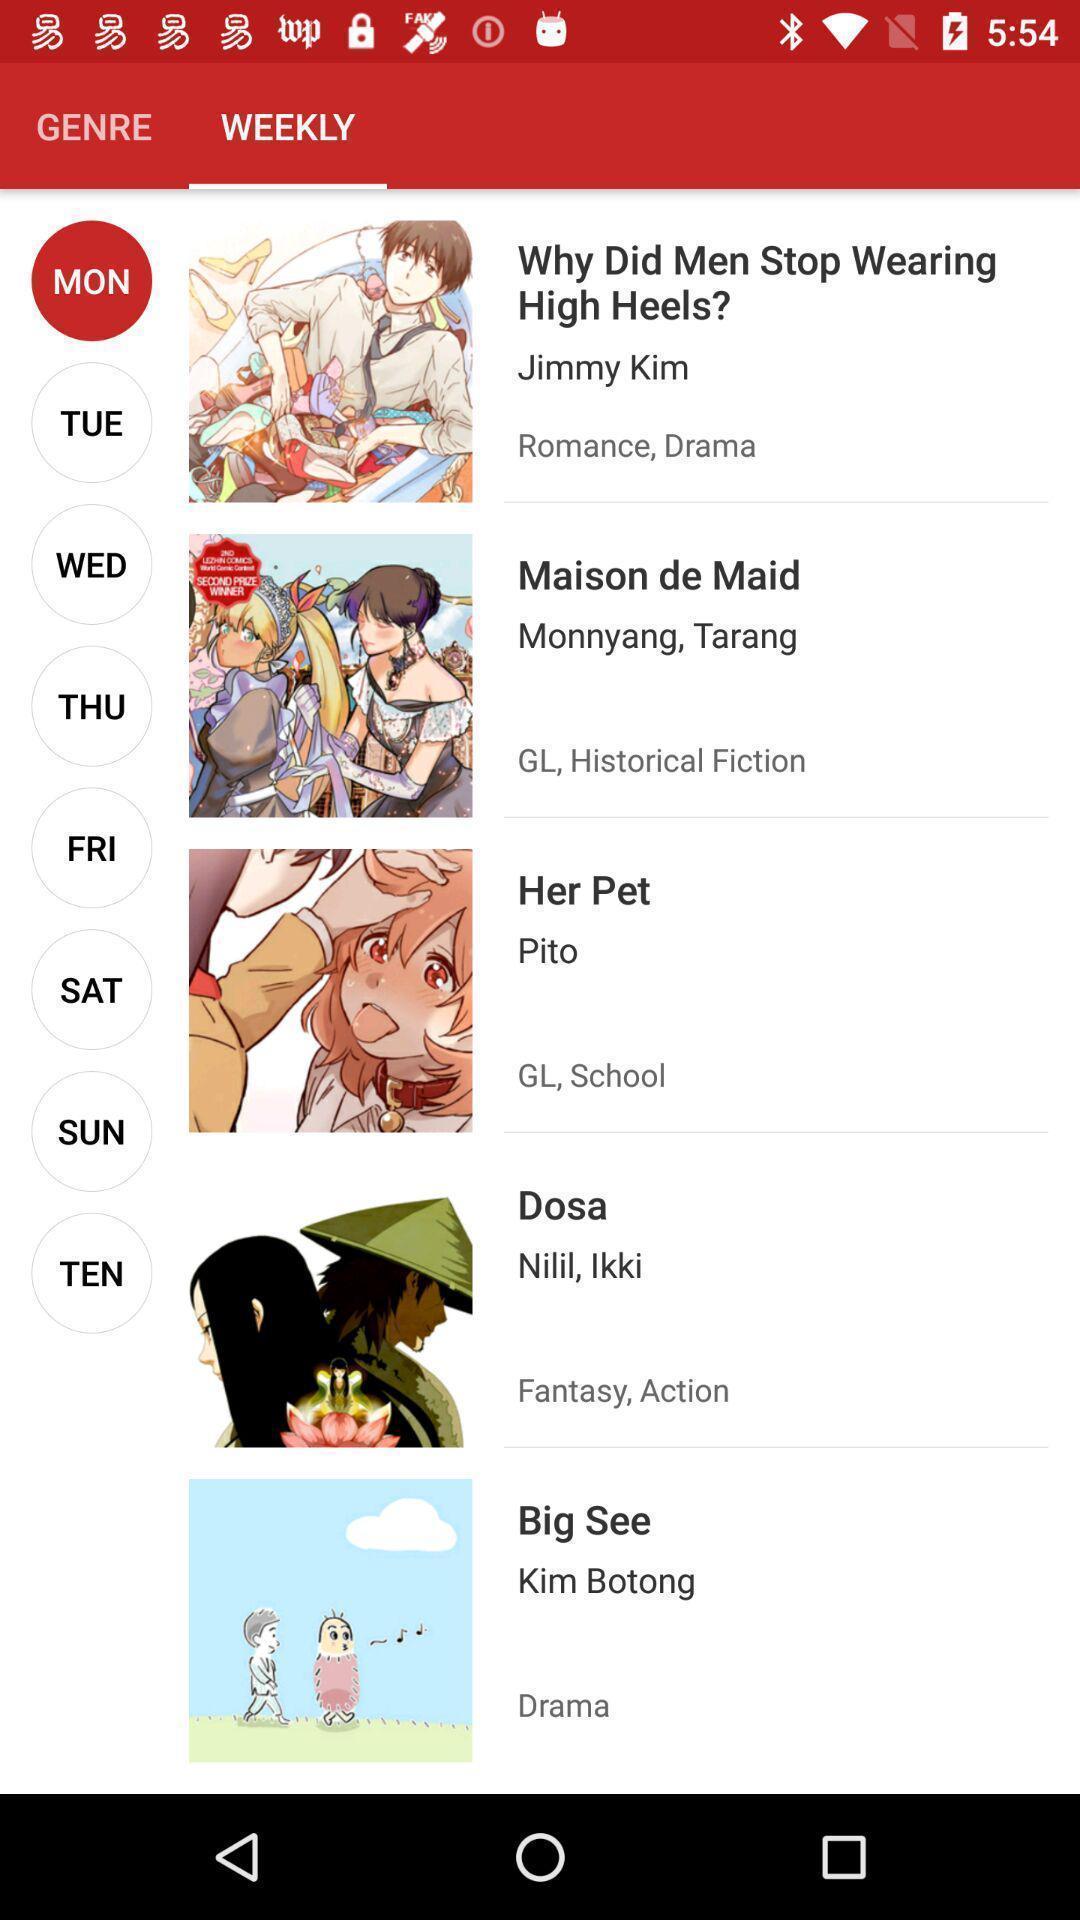Explain what's happening in this screen capture. Page displaying various information. 